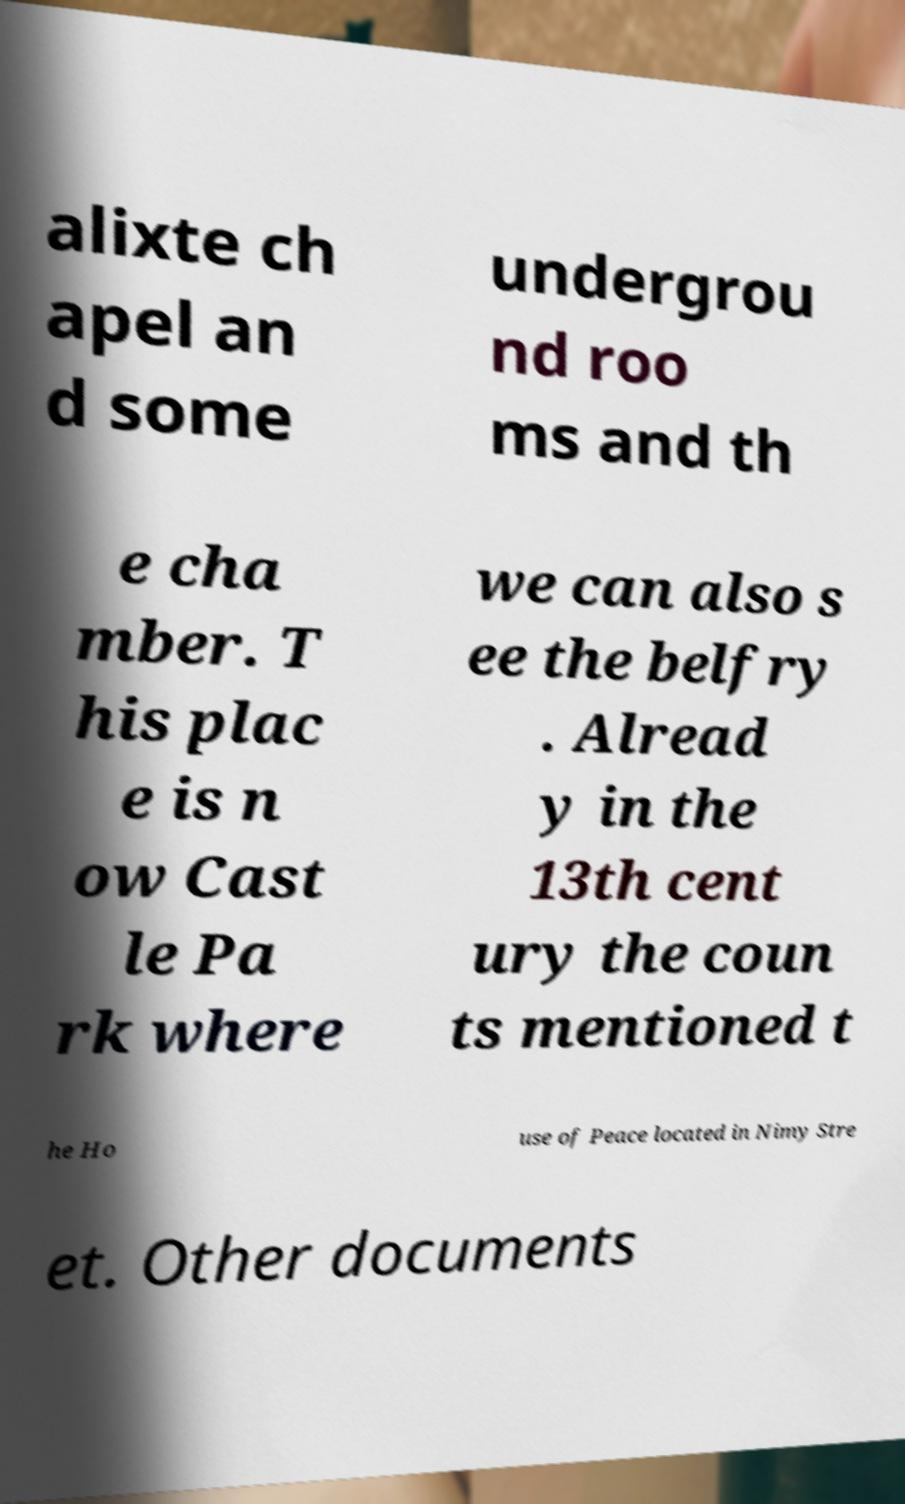Could you extract and type out the text from this image? alixte ch apel an d some undergrou nd roo ms and th e cha mber. T his plac e is n ow Cast le Pa rk where we can also s ee the belfry . Alread y in the 13th cent ury the coun ts mentioned t he Ho use of Peace located in Nimy Stre et. Other documents 